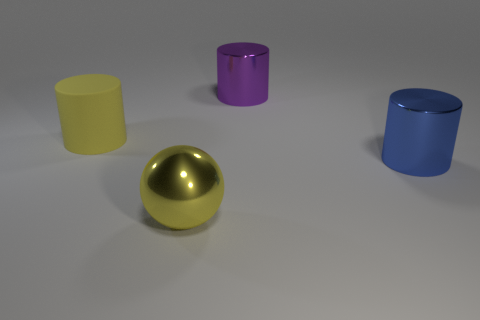The large thing in front of the cylinder that is to the right of the large metallic cylinder to the left of the large blue shiny object is what color?
Offer a terse response. Yellow. There is a thing that is on the left side of the yellow metallic object; does it have the same shape as the big yellow metallic object?
Keep it short and to the point. No. The matte cylinder that is the same size as the sphere is what color?
Offer a terse response. Yellow. How many gray spheres are there?
Your answer should be compact. 0. Are the object that is to the right of the purple shiny cylinder and the large purple cylinder made of the same material?
Your answer should be compact. Yes. What is the large thing that is right of the big sphere and on the left side of the blue cylinder made of?
Your answer should be very brief. Metal. There is a cylinder that is the same color as the metallic sphere; what is its size?
Offer a terse response. Large. There is a big yellow object in front of the object that is left of the yellow ball; what is its material?
Your response must be concise. Metal. What number of other large things have the same material as the purple object?
Give a very brief answer. 2. What is the color of the large metal cylinder in front of the cylinder to the left of the big yellow shiny object?
Make the answer very short. Blue. 